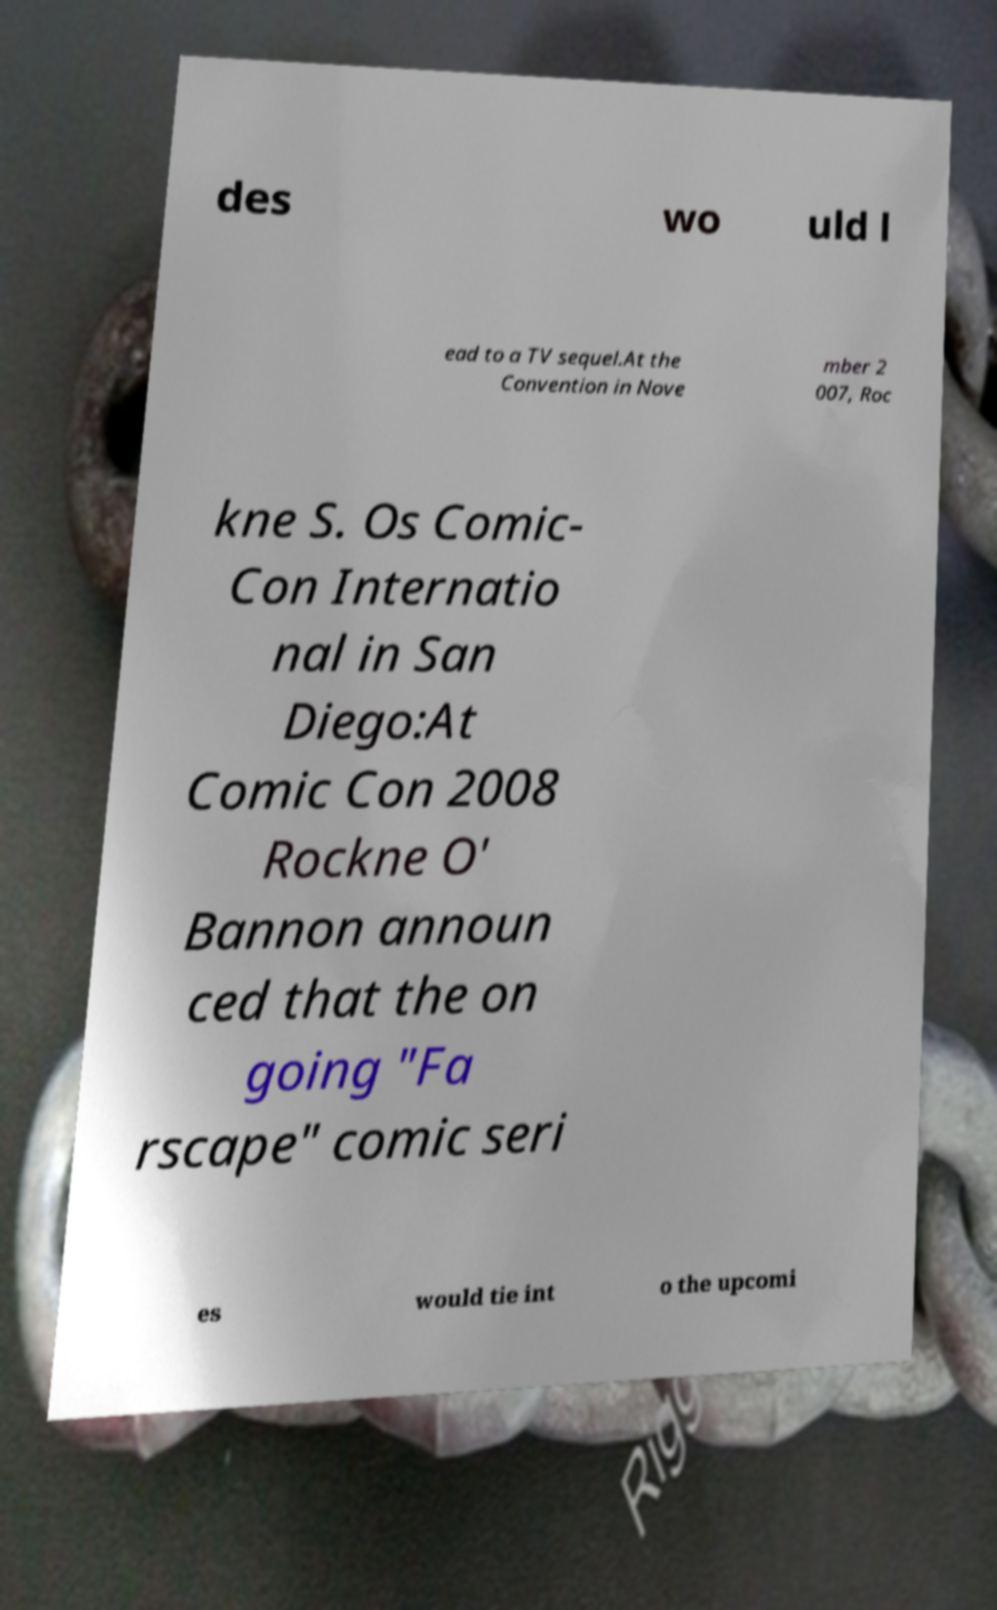What messages or text are displayed in this image? I need them in a readable, typed format. des wo uld l ead to a TV sequel.At the Convention in Nove mber 2 007, Roc kne S. Os Comic- Con Internatio nal in San Diego:At Comic Con 2008 Rockne O' Bannon announ ced that the on going "Fa rscape" comic seri es would tie int o the upcomi 